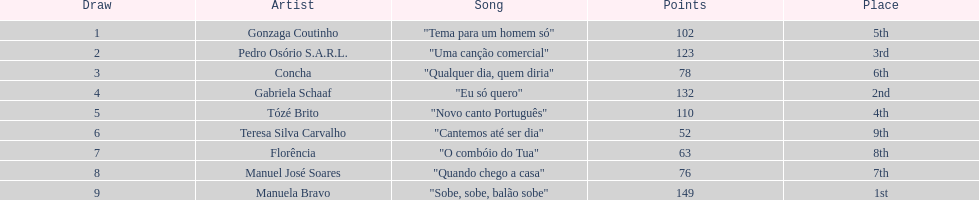Who was the final selection? Manuela Bravo. 